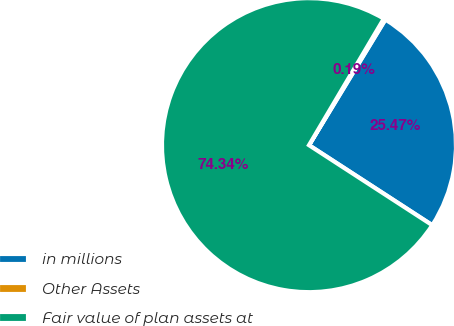Convert chart to OTSL. <chart><loc_0><loc_0><loc_500><loc_500><pie_chart><fcel>in millions<fcel>Other Assets<fcel>Fair value of plan assets at<nl><fcel>25.47%<fcel>0.19%<fcel>74.34%<nl></chart> 